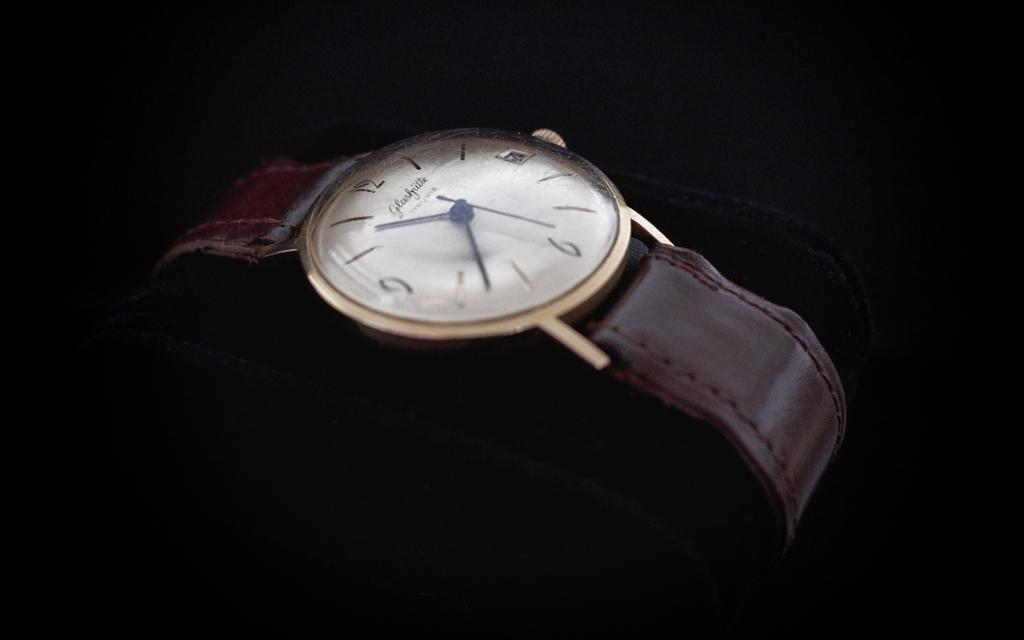Provide a one-sentence caption for the provided image. A watch with a brown leather band shows 10:38. 